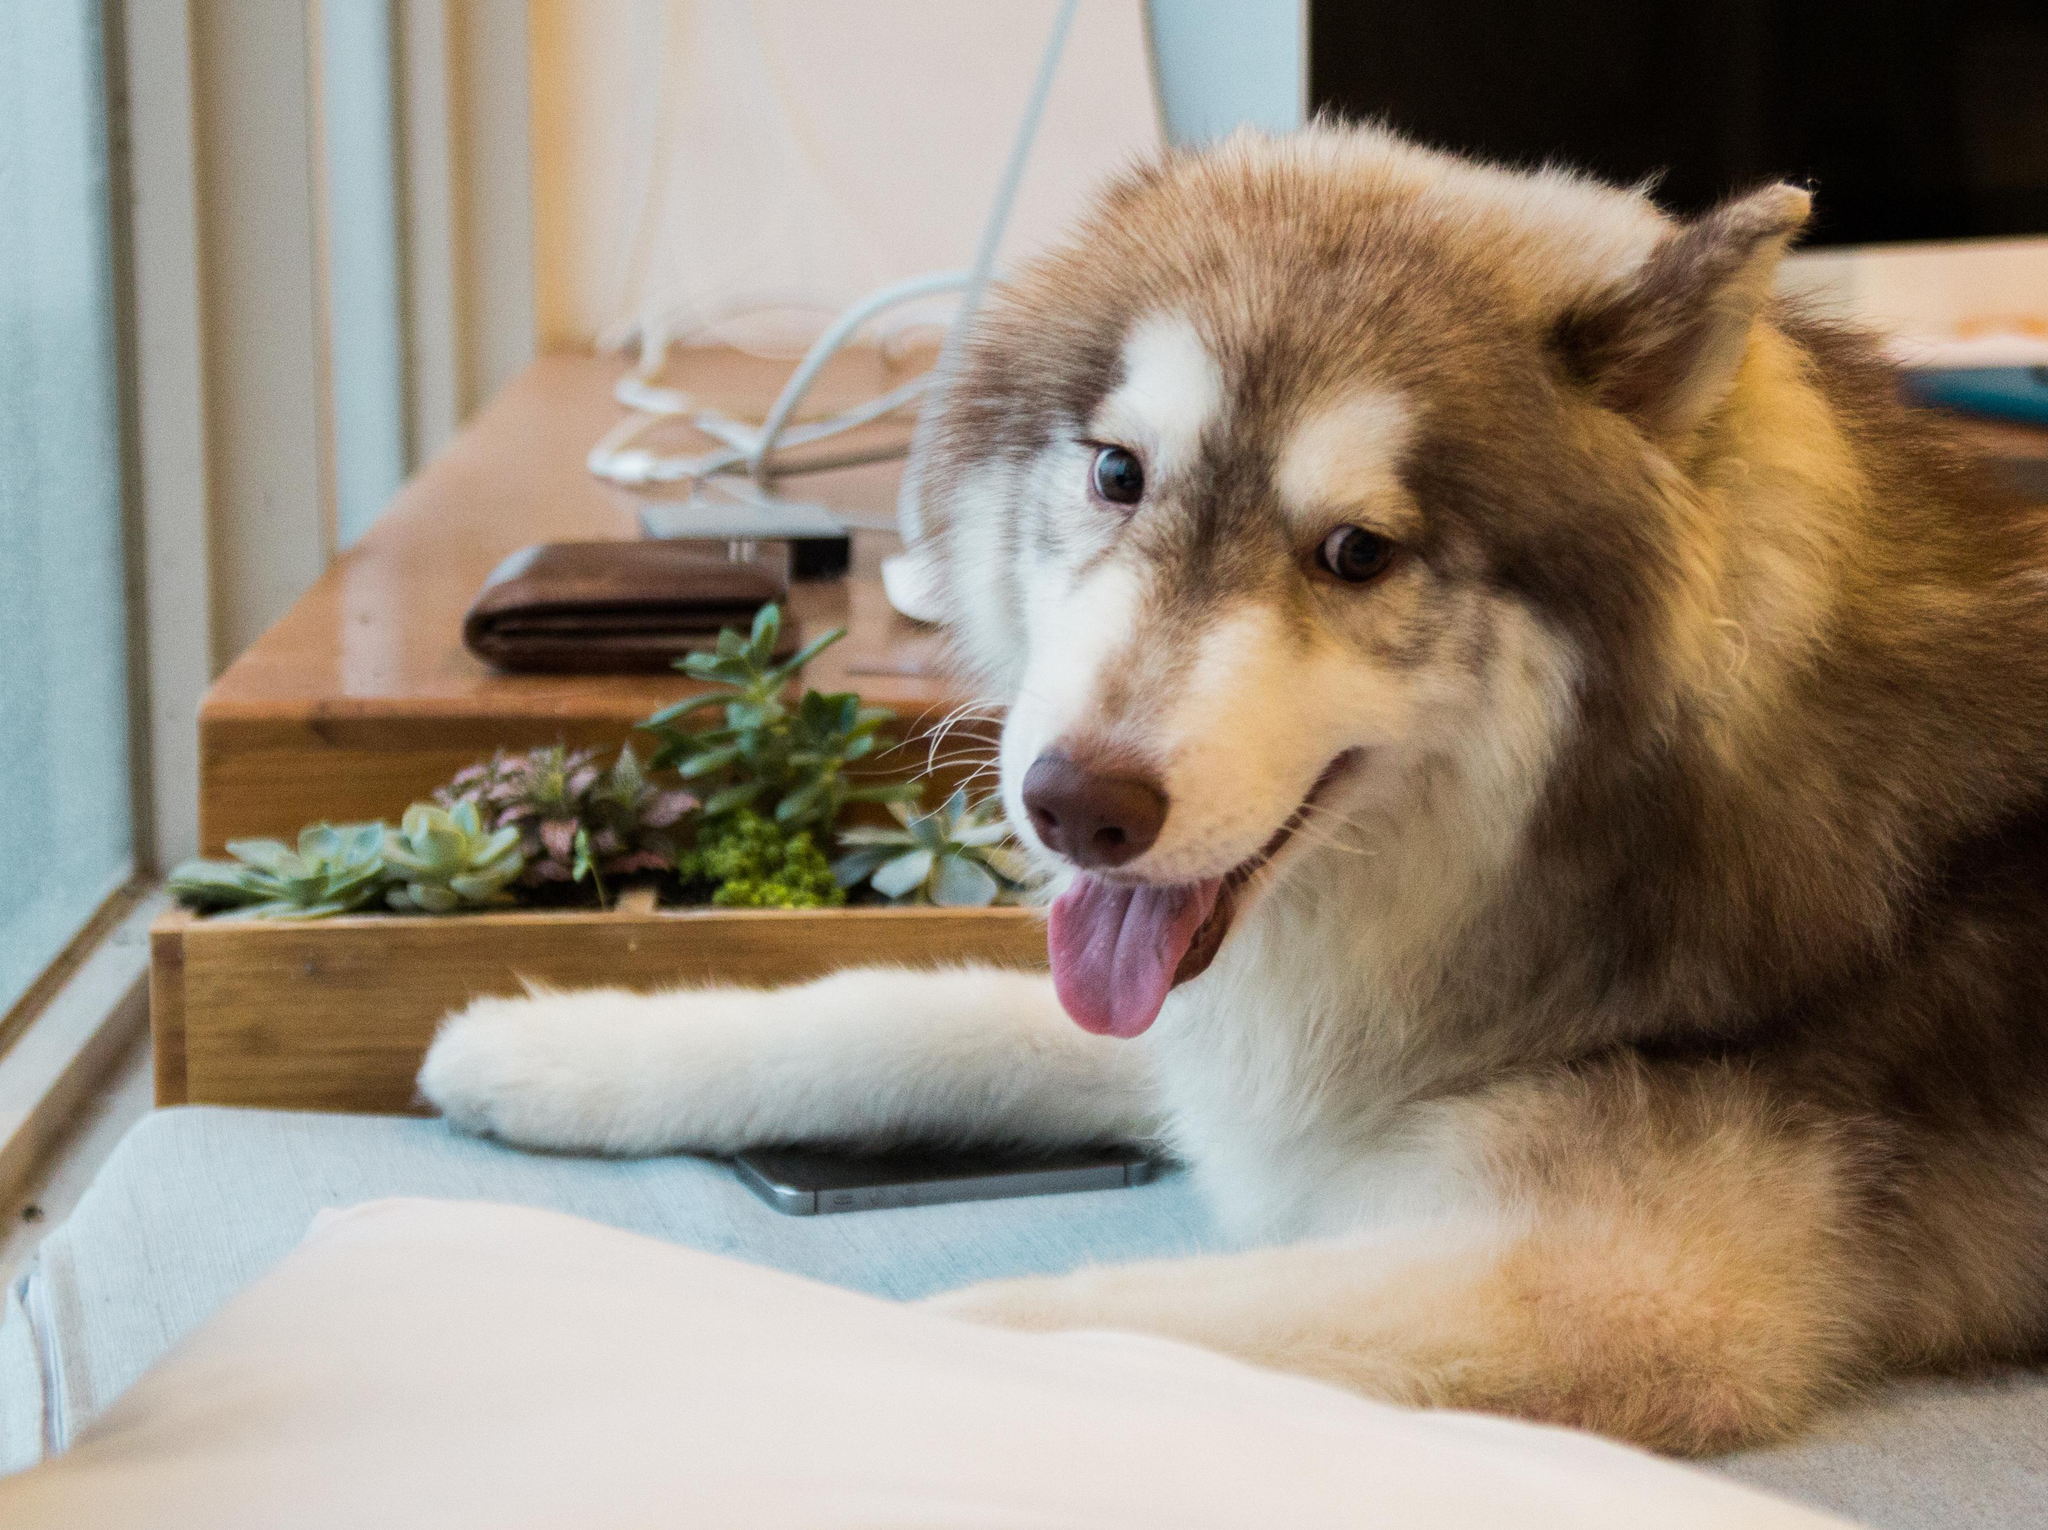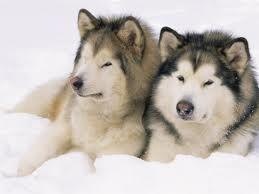The first image is the image on the left, the second image is the image on the right. Assess this claim about the two images: "An image shows two adult huskies reclining side-by-side in the snow, with a dusting of snow on their fur.". Correct or not? Answer yes or no. Yes. The first image is the image on the left, the second image is the image on the right. Examine the images to the left and right. Is the description "There is one dog who is not in the snow." accurate? Answer yes or no. Yes. 